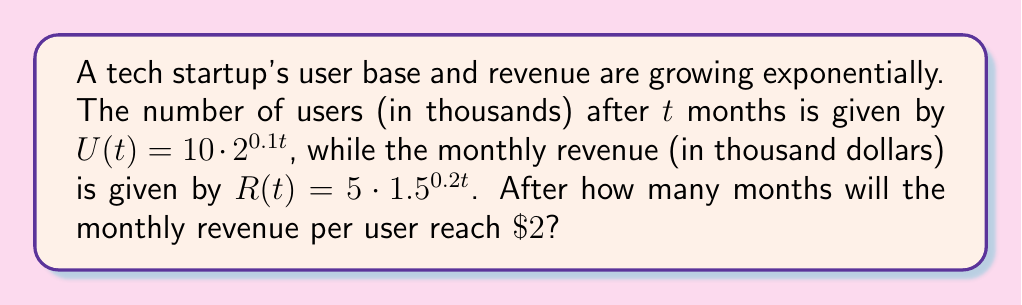Provide a solution to this math problem. To solve this problem, we need to follow these steps:

1) First, let's define the revenue per user function:
   $RPU(t) = \frac{R(t)}{U(t)}$

2) We want to find t when $RPU(t) = 2$. So, we set up the equation:
   $$\frac{R(t)}{U(t)} = 2$$

3) Substitute the given functions:
   $$\frac{5 \cdot 1.5^{0.2t}}{10 \cdot 2^{0.1t}} = 2$$

4) Simplify:
   $$\frac{1.5^{0.2t}}{4 \cdot 2^{0.1t}} = 1$$

5) Multiply both sides by $4 \cdot 2^{0.1t}$:
   $$1.5^{0.2t} = 4 \cdot 2^{0.1t}$$

6) Take the natural log of both sides:
   $$0.2t \cdot \ln(1.5) = \ln(4) + 0.1t \cdot \ln(2)$$

7) Simplify:
   $$0.2t \cdot 0.4055 = 1.3863 + 0.1t \cdot 0.6931$$

8) Solve for t:
   $$0.0811t - 0.06931t = 1.3863$$
   $$0.01179t = 1.3863$$
   $$t = \frac{1.3863}{0.01179} \approx 117.58$$

9) Round to the nearest whole month:
   $t = 118$ months
Answer: 118 months 